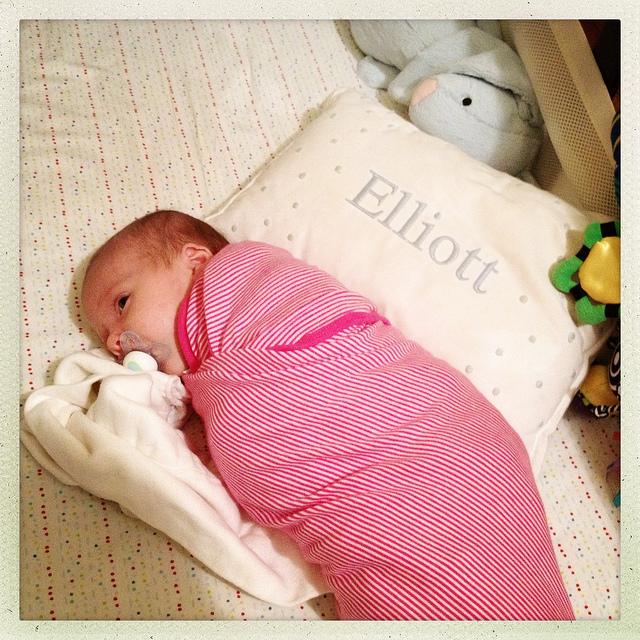Is the baby a boy or girl?
Answer briefly. Boy. What is the baby's name?
Give a very brief answer. Elliott. Is the baby sleeping?
Answer briefly. No. 